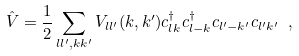<formula> <loc_0><loc_0><loc_500><loc_500>\hat { V } = \frac { 1 } { 2 } \sum _ { l l ^ { \prime } , { k } { k } ^ { \prime } } V _ { l l ^ { \prime } } ( { k } , { k } ^ { \prime } ) c ^ { \dag } _ { l { k } } c ^ { \dag } _ { l - { k } } c _ { l ^ { \prime } - { k } ^ { \prime } } c _ { l ^ { \prime } { k } ^ { \prime } } \ ,</formula> 